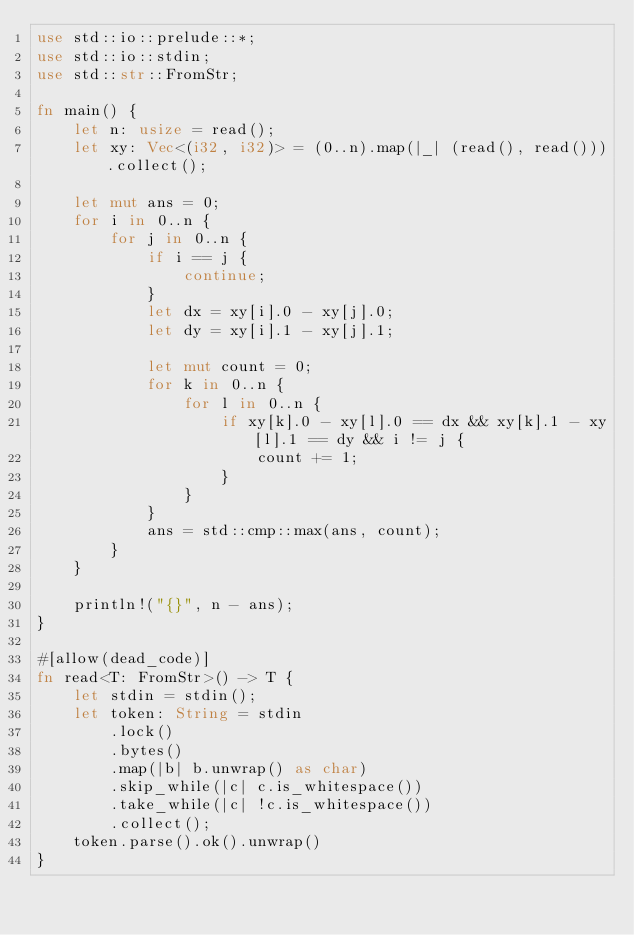<code> <loc_0><loc_0><loc_500><loc_500><_Rust_>use std::io::prelude::*;
use std::io::stdin;
use std::str::FromStr;

fn main() {
    let n: usize = read();
    let xy: Vec<(i32, i32)> = (0..n).map(|_| (read(), read())).collect();

    let mut ans = 0;
    for i in 0..n {
        for j in 0..n {
            if i == j {
                continue;
            }
            let dx = xy[i].0 - xy[j].0;
            let dy = xy[i].1 - xy[j].1;

            let mut count = 0;
            for k in 0..n {
                for l in 0..n {
                    if xy[k].0 - xy[l].0 == dx && xy[k].1 - xy[l].1 == dy && i != j {
                        count += 1;
                    }
                }
            }
            ans = std::cmp::max(ans, count);
        }
    }

    println!("{}", n - ans);
}

#[allow(dead_code)]
fn read<T: FromStr>() -> T {
    let stdin = stdin();
    let token: String = stdin
        .lock()
        .bytes()
        .map(|b| b.unwrap() as char)
        .skip_while(|c| c.is_whitespace())
        .take_while(|c| !c.is_whitespace())
        .collect();
    token.parse().ok().unwrap()
}
</code> 